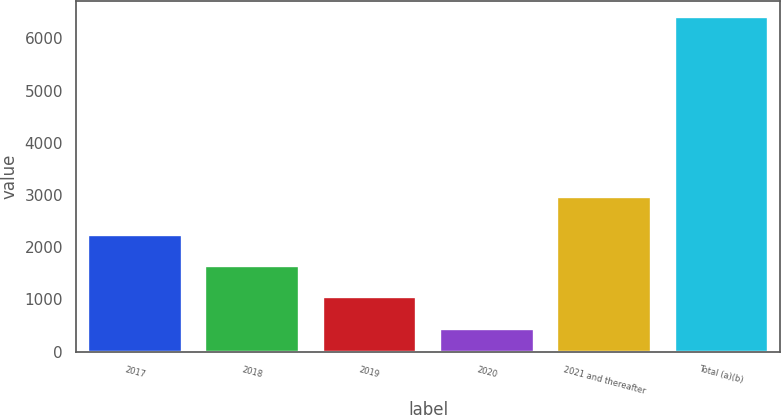<chart> <loc_0><loc_0><loc_500><loc_500><bar_chart><fcel>2017<fcel>2018<fcel>2019<fcel>2020<fcel>2021 and thereafter<fcel>Total (a)(b)<nl><fcel>2229.7<fcel>1633.8<fcel>1037.9<fcel>442<fcel>2960<fcel>6401<nl></chart> 